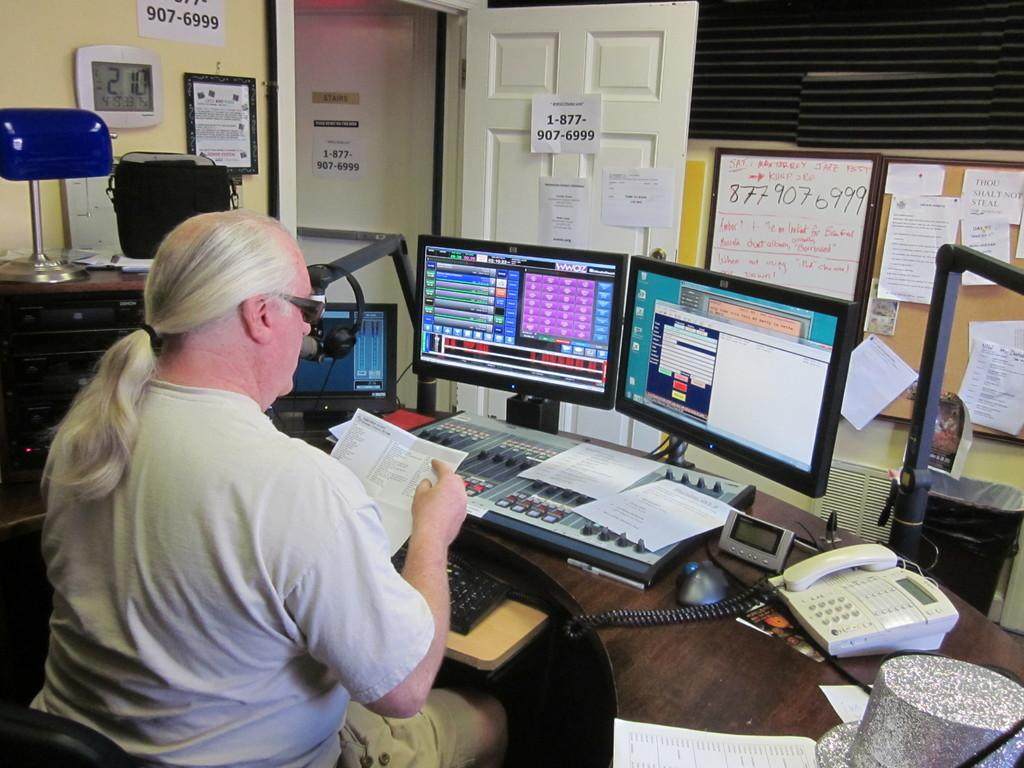<image>
Summarize the visual content of the image. Person using a computer inside a room with the numbnner 18779076999 on the door.' 